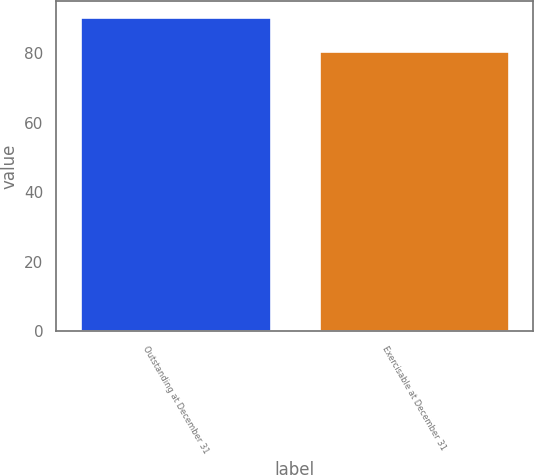Convert chart to OTSL. <chart><loc_0><loc_0><loc_500><loc_500><bar_chart><fcel>Outstanding at December 31<fcel>Exercisable at December 31<nl><fcel>90.42<fcel>80.5<nl></chart> 